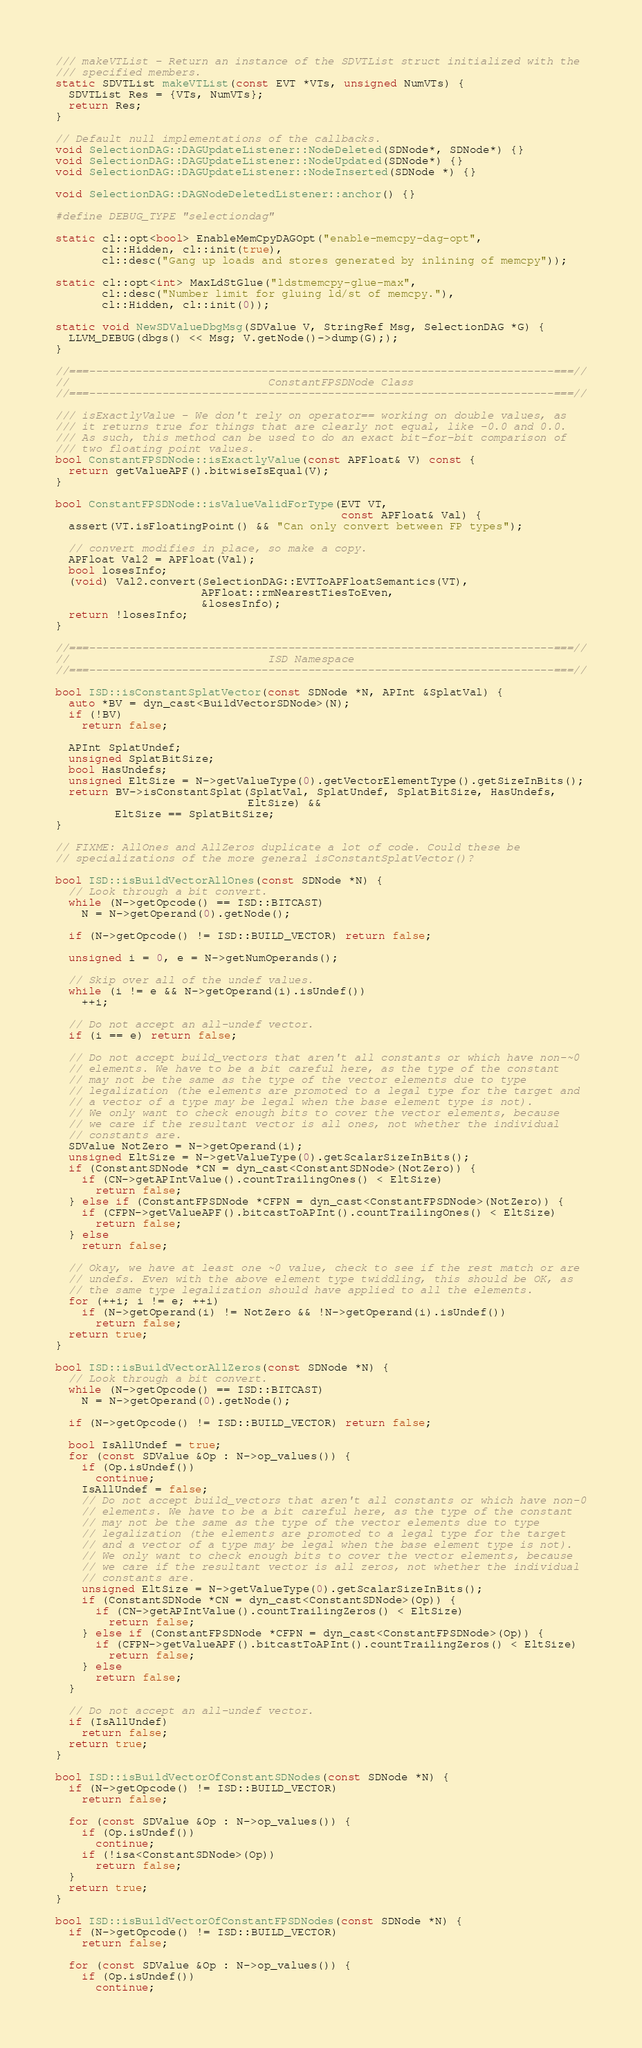Convert code to text. <code><loc_0><loc_0><loc_500><loc_500><_C++_>
/// makeVTList - Return an instance of the SDVTList struct initialized with the
/// specified members.
static SDVTList makeVTList(const EVT *VTs, unsigned NumVTs) {
  SDVTList Res = {VTs, NumVTs};
  return Res;
}

// Default null implementations of the callbacks.
void SelectionDAG::DAGUpdateListener::NodeDeleted(SDNode*, SDNode*) {}
void SelectionDAG::DAGUpdateListener::NodeUpdated(SDNode*) {}
void SelectionDAG::DAGUpdateListener::NodeInserted(SDNode *) {}

void SelectionDAG::DAGNodeDeletedListener::anchor() {}

#define DEBUG_TYPE "selectiondag"

static cl::opt<bool> EnableMemCpyDAGOpt("enable-memcpy-dag-opt",
       cl::Hidden, cl::init(true),
       cl::desc("Gang up loads and stores generated by inlining of memcpy"));

static cl::opt<int> MaxLdStGlue("ldstmemcpy-glue-max",
       cl::desc("Number limit for gluing ld/st of memcpy."),
       cl::Hidden, cl::init(0));

static void NewSDValueDbgMsg(SDValue V, StringRef Msg, SelectionDAG *G) {
  LLVM_DEBUG(dbgs() << Msg; V.getNode()->dump(G););
}

//===----------------------------------------------------------------------===//
//                              ConstantFPSDNode Class
//===----------------------------------------------------------------------===//

/// isExactlyValue - We don't rely on operator== working on double values, as
/// it returns true for things that are clearly not equal, like -0.0 and 0.0.
/// As such, this method can be used to do an exact bit-for-bit comparison of
/// two floating point values.
bool ConstantFPSDNode::isExactlyValue(const APFloat& V) const {
  return getValueAPF().bitwiseIsEqual(V);
}

bool ConstantFPSDNode::isValueValidForType(EVT VT,
                                           const APFloat& Val) {
  assert(VT.isFloatingPoint() && "Can only convert between FP types");

  // convert modifies in place, so make a copy.
  APFloat Val2 = APFloat(Val);
  bool losesInfo;
  (void) Val2.convert(SelectionDAG::EVTToAPFloatSemantics(VT),
                      APFloat::rmNearestTiesToEven,
                      &losesInfo);
  return !losesInfo;
}

//===----------------------------------------------------------------------===//
//                              ISD Namespace
//===----------------------------------------------------------------------===//

bool ISD::isConstantSplatVector(const SDNode *N, APInt &SplatVal) {
  auto *BV = dyn_cast<BuildVectorSDNode>(N);
  if (!BV)
    return false;

  APInt SplatUndef;
  unsigned SplatBitSize;
  bool HasUndefs;
  unsigned EltSize = N->getValueType(0).getVectorElementType().getSizeInBits();
  return BV->isConstantSplat(SplatVal, SplatUndef, SplatBitSize, HasUndefs,
                             EltSize) &&
         EltSize == SplatBitSize;
}

// FIXME: AllOnes and AllZeros duplicate a lot of code. Could these be
// specializations of the more general isConstantSplatVector()?

bool ISD::isBuildVectorAllOnes(const SDNode *N) {
  // Look through a bit convert.
  while (N->getOpcode() == ISD::BITCAST)
    N = N->getOperand(0).getNode();

  if (N->getOpcode() != ISD::BUILD_VECTOR) return false;

  unsigned i = 0, e = N->getNumOperands();

  // Skip over all of the undef values.
  while (i != e && N->getOperand(i).isUndef())
    ++i;

  // Do not accept an all-undef vector.
  if (i == e) return false;

  // Do not accept build_vectors that aren't all constants or which have non-~0
  // elements. We have to be a bit careful here, as the type of the constant
  // may not be the same as the type of the vector elements due to type
  // legalization (the elements are promoted to a legal type for the target and
  // a vector of a type may be legal when the base element type is not).
  // We only want to check enough bits to cover the vector elements, because
  // we care if the resultant vector is all ones, not whether the individual
  // constants are.
  SDValue NotZero = N->getOperand(i);
  unsigned EltSize = N->getValueType(0).getScalarSizeInBits();
  if (ConstantSDNode *CN = dyn_cast<ConstantSDNode>(NotZero)) {
    if (CN->getAPIntValue().countTrailingOnes() < EltSize)
      return false;
  } else if (ConstantFPSDNode *CFPN = dyn_cast<ConstantFPSDNode>(NotZero)) {
    if (CFPN->getValueAPF().bitcastToAPInt().countTrailingOnes() < EltSize)
      return false;
  } else
    return false;

  // Okay, we have at least one ~0 value, check to see if the rest match or are
  // undefs. Even with the above element type twiddling, this should be OK, as
  // the same type legalization should have applied to all the elements.
  for (++i; i != e; ++i)
    if (N->getOperand(i) != NotZero && !N->getOperand(i).isUndef())
      return false;
  return true;
}

bool ISD::isBuildVectorAllZeros(const SDNode *N) {
  // Look through a bit convert.
  while (N->getOpcode() == ISD::BITCAST)
    N = N->getOperand(0).getNode();

  if (N->getOpcode() != ISD::BUILD_VECTOR) return false;

  bool IsAllUndef = true;
  for (const SDValue &Op : N->op_values()) {
    if (Op.isUndef())
      continue;
    IsAllUndef = false;
    // Do not accept build_vectors that aren't all constants or which have non-0
    // elements. We have to be a bit careful here, as the type of the constant
    // may not be the same as the type of the vector elements due to type
    // legalization (the elements are promoted to a legal type for the target
    // and a vector of a type may be legal when the base element type is not).
    // We only want to check enough bits to cover the vector elements, because
    // we care if the resultant vector is all zeros, not whether the individual
    // constants are.
    unsigned EltSize = N->getValueType(0).getScalarSizeInBits();
    if (ConstantSDNode *CN = dyn_cast<ConstantSDNode>(Op)) {
      if (CN->getAPIntValue().countTrailingZeros() < EltSize)
        return false;
    } else if (ConstantFPSDNode *CFPN = dyn_cast<ConstantFPSDNode>(Op)) {
      if (CFPN->getValueAPF().bitcastToAPInt().countTrailingZeros() < EltSize)
        return false;
    } else
      return false;
  }

  // Do not accept an all-undef vector.
  if (IsAllUndef)
    return false;
  return true;
}

bool ISD::isBuildVectorOfConstantSDNodes(const SDNode *N) {
  if (N->getOpcode() != ISD::BUILD_VECTOR)
    return false;

  for (const SDValue &Op : N->op_values()) {
    if (Op.isUndef())
      continue;
    if (!isa<ConstantSDNode>(Op))
      return false;
  }
  return true;
}

bool ISD::isBuildVectorOfConstantFPSDNodes(const SDNode *N) {
  if (N->getOpcode() != ISD::BUILD_VECTOR)
    return false;

  for (const SDValue &Op : N->op_values()) {
    if (Op.isUndef())
      continue;</code> 